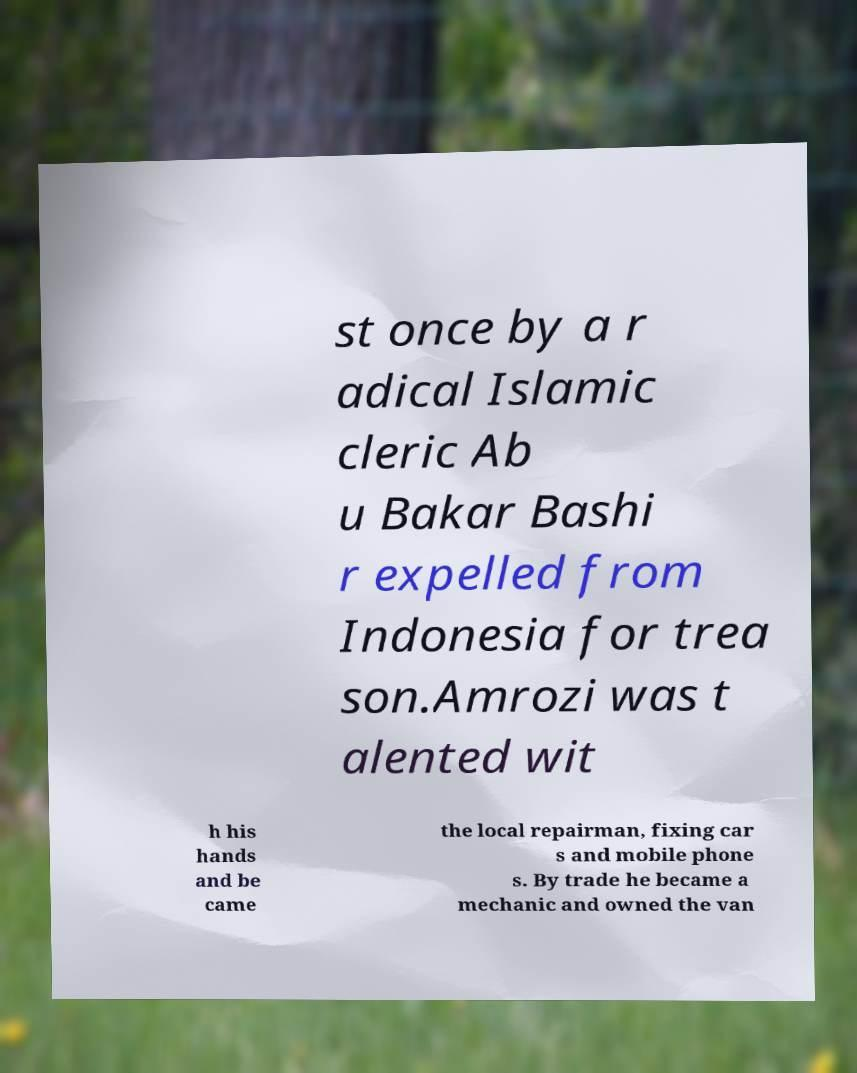Please read and relay the text visible in this image. What does it say? st once by a r adical Islamic cleric Ab u Bakar Bashi r expelled from Indonesia for trea son.Amrozi was t alented wit h his hands and be came the local repairman, fixing car s and mobile phone s. By trade he became a mechanic and owned the van 